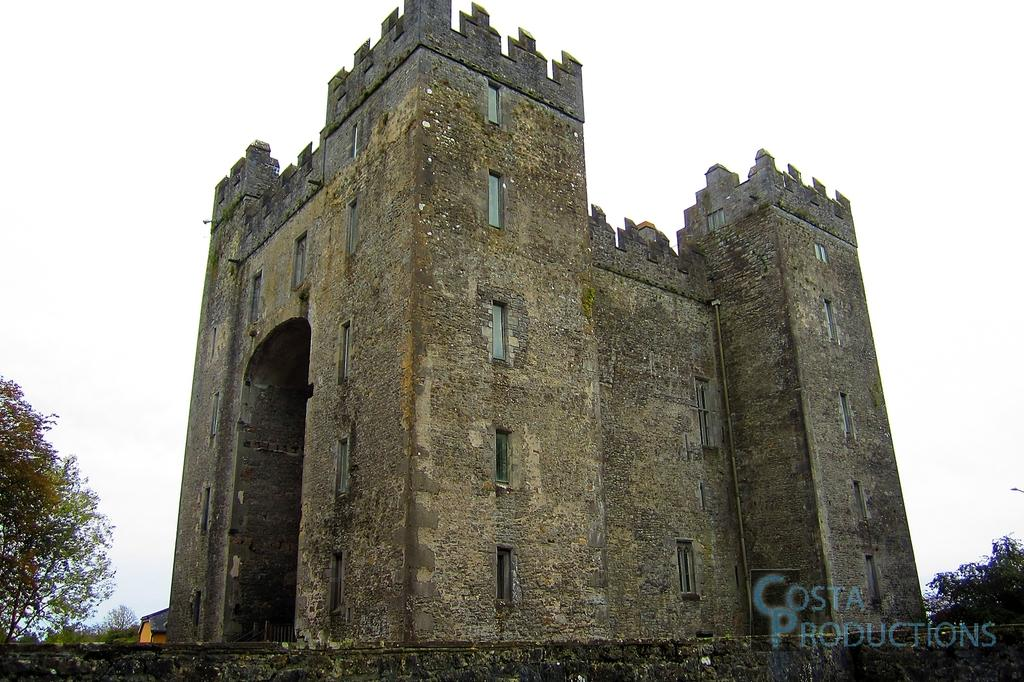What type of architecture can be seen in the image? There is old architecture visible in the image. What is the main structure in the image? There is a building in the image. What can be seen in the background of the image? Trees and the sky are visible in the background of the image. Is there any indication of the image's origin or ownership? Yes, there is a watermark on the image. Can you hear the yak laughing in the image? There is no yak or laughter present in the image; it features an old building with trees and the sky in the background. 